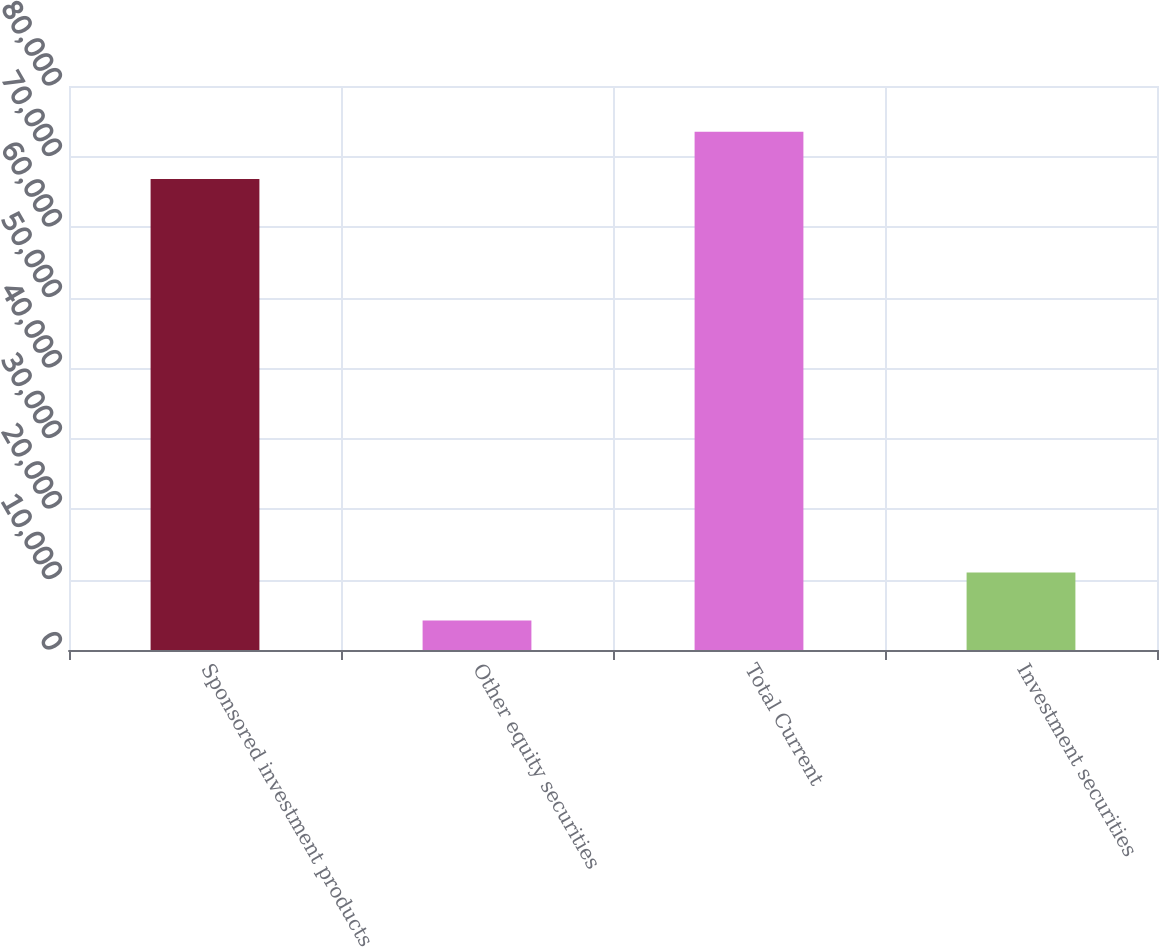<chart> <loc_0><loc_0><loc_500><loc_500><bar_chart><fcel>Sponsored investment products<fcel>Other equity securities<fcel>Total Current<fcel>Investment securities<nl><fcel>66816<fcel>4174<fcel>73497.6<fcel>11000<nl></chart> 